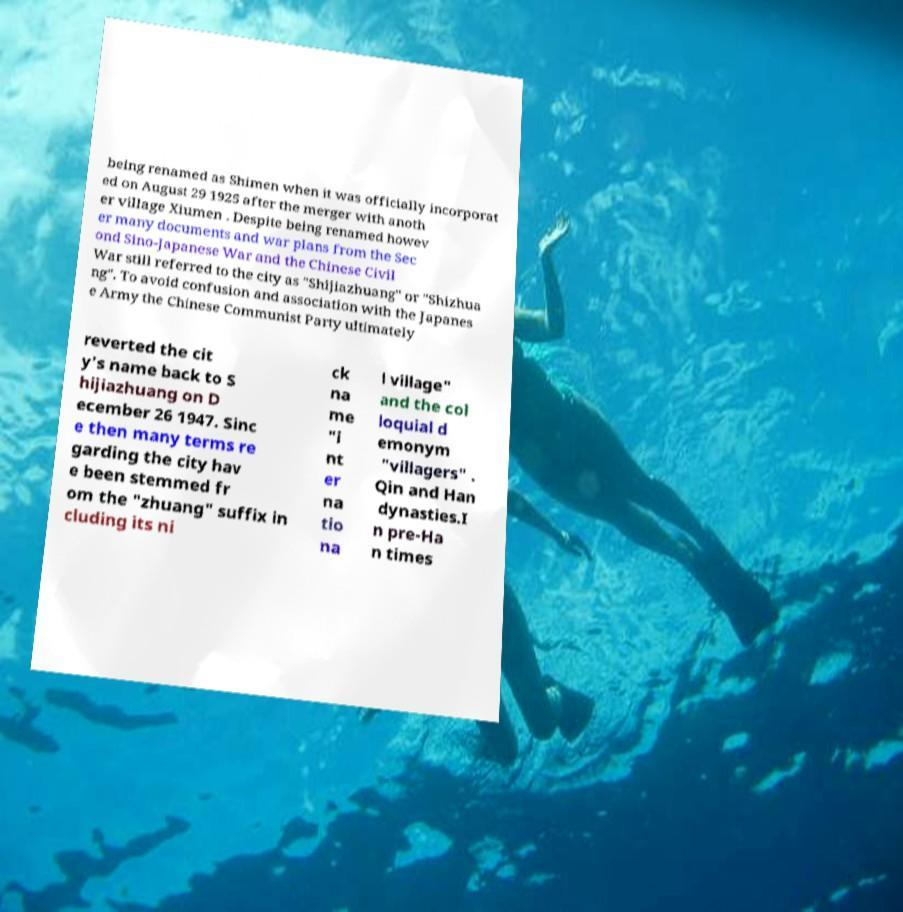Please read and relay the text visible in this image. What does it say? being renamed as Shimen when it was officially incorporat ed on August 29 1925 after the merger with anoth er village Xiumen . Despite being renamed howev er many documents and war plans from the Sec ond Sino-Japanese War and the Chinese Civil War still referred to the city as "Shijiazhuang" or "Shizhua ng". To avoid confusion and association with the Japanes e Army the Chinese Communist Party ultimately reverted the cit y's name back to S hijiazhuang on D ecember 26 1947. Sinc e then many terms re garding the city hav e been stemmed fr om the "zhuang" suffix in cluding its ni ck na me "i nt er na tio na l village" and the col loquial d emonym "villagers" . Qin and Han dynasties.I n pre-Ha n times 